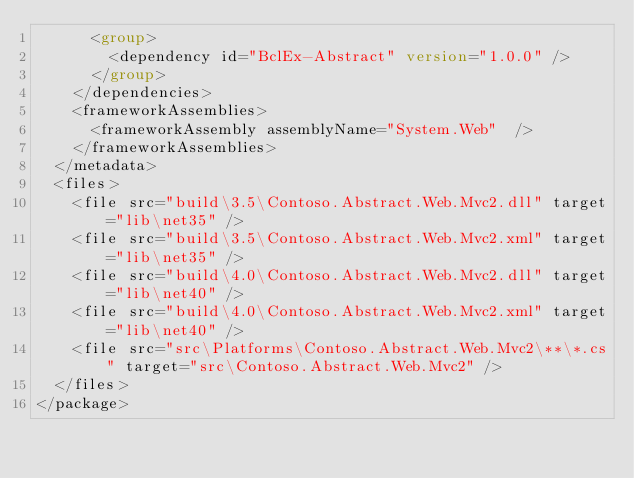Convert code to text. <code><loc_0><loc_0><loc_500><loc_500><_XML_>      <group>
        <dependency id="BclEx-Abstract" version="1.0.0" />
      </group>
    </dependencies>
    <frameworkAssemblies>
      <frameworkAssembly assemblyName="System.Web"  />
    </frameworkAssemblies>
  </metadata>
  <files>
    <file src="build\3.5\Contoso.Abstract.Web.Mvc2.dll" target="lib\net35" />
    <file src="build\3.5\Contoso.Abstract.Web.Mvc2.xml" target="lib\net35" />
    <file src="build\4.0\Contoso.Abstract.Web.Mvc2.dll" target="lib\net40" />
    <file src="build\4.0\Contoso.Abstract.Web.Mvc2.xml" target="lib\net40" />
    <file src="src\Platforms\Contoso.Abstract.Web.Mvc2\**\*.cs" target="src\Contoso.Abstract.Web.Mvc2" />
  </files>
</package>
</code> 